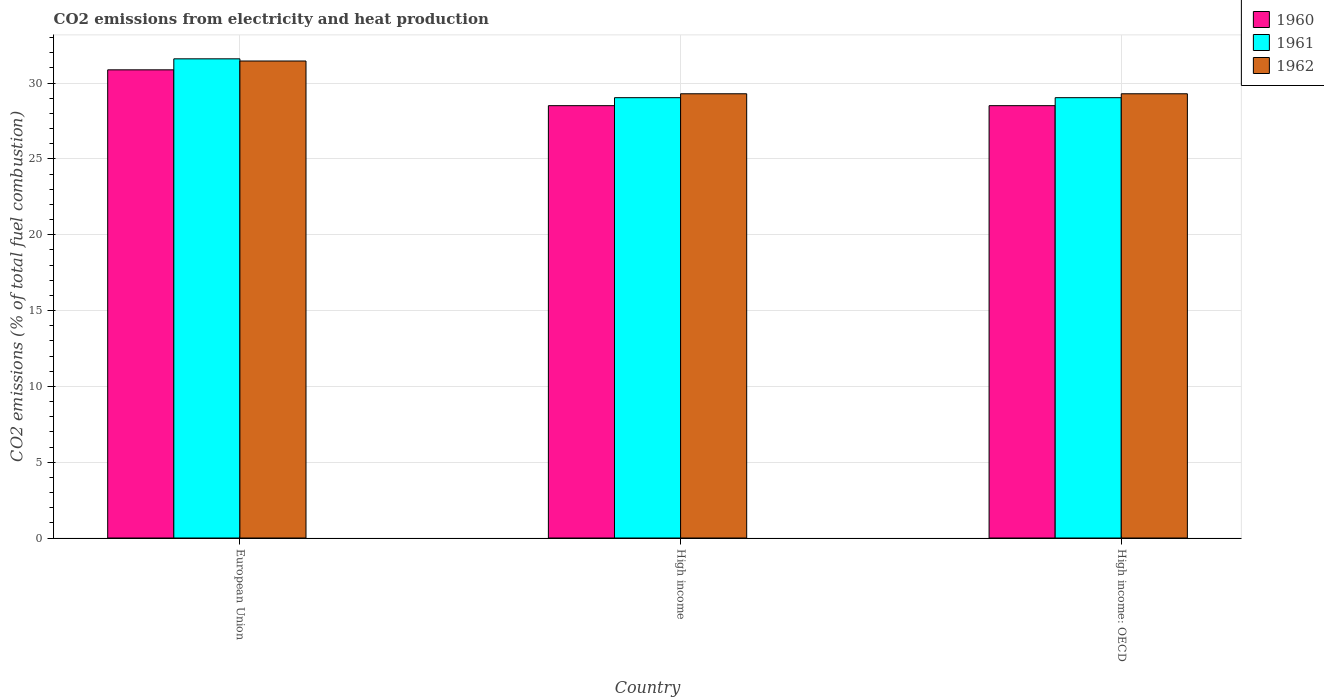How many groups of bars are there?
Make the answer very short. 3. How many bars are there on the 2nd tick from the left?
Offer a terse response. 3. How many bars are there on the 1st tick from the right?
Provide a short and direct response. 3. What is the amount of CO2 emitted in 1961 in European Union?
Make the answer very short. 31.59. Across all countries, what is the maximum amount of CO2 emitted in 1961?
Your answer should be very brief. 31.59. Across all countries, what is the minimum amount of CO2 emitted in 1960?
Give a very brief answer. 28.51. In which country was the amount of CO2 emitted in 1961 maximum?
Ensure brevity in your answer.  European Union. What is the total amount of CO2 emitted in 1960 in the graph?
Provide a succinct answer. 87.88. What is the difference between the amount of CO2 emitted in 1960 in European Union and that in High income: OECD?
Provide a short and direct response. 2.36. What is the difference between the amount of CO2 emitted in 1960 in European Union and the amount of CO2 emitted in 1962 in High income: OECD?
Provide a succinct answer. 1.58. What is the average amount of CO2 emitted in 1961 per country?
Keep it short and to the point. 29.89. What is the difference between the amount of CO2 emitted of/in 1961 and amount of CO2 emitted of/in 1962 in European Union?
Your answer should be very brief. 0.14. In how many countries, is the amount of CO2 emitted in 1961 greater than 14 %?
Keep it short and to the point. 3. Is the amount of CO2 emitted in 1960 in High income less than that in High income: OECD?
Keep it short and to the point. No. Is the difference between the amount of CO2 emitted in 1961 in European Union and High income greater than the difference between the amount of CO2 emitted in 1962 in European Union and High income?
Provide a succinct answer. Yes. What is the difference between the highest and the second highest amount of CO2 emitted in 1961?
Offer a terse response. -2.56. What is the difference between the highest and the lowest amount of CO2 emitted in 1962?
Your response must be concise. 2.16. In how many countries, is the amount of CO2 emitted in 1962 greater than the average amount of CO2 emitted in 1962 taken over all countries?
Your answer should be compact. 1. What does the 1st bar from the left in High income represents?
Offer a terse response. 1960. How many bars are there?
Keep it short and to the point. 9. How many countries are there in the graph?
Your response must be concise. 3. What is the difference between two consecutive major ticks on the Y-axis?
Provide a succinct answer. 5. Does the graph contain any zero values?
Offer a terse response. No. What is the title of the graph?
Offer a terse response. CO2 emissions from electricity and heat production. Does "2013" appear as one of the legend labels in the graph?
Provide a succinct answer. No. What is the label or title of the X-axis?
Make the answer very short. Country. What is the label or title of the Y-axis?
Ensure brevity in your answer.  CO2 emissions (% of total fuel combustion). What is the CO2 emissions (% of total fuel combustion) of 1960 in European Union?
Provide a short and direct response. 30.87. What is the CO2 emissions (% of total fuel combustion) of 1961 in European Union?
Provide a short and direct response. 31.59. What is the CO2 emissions (% of total fuel combustion) in 1962 in European Union?
Your response must be concise. 31.45. What is the CO2 emissions (% of total fuel combustion) in 1960 in High income?
Ensure brevity in your answer.  28.51. What is the CO2 emissions (% of total fuel combustion) of 1961 in High income?
Offer a very short reply. 29.03. What is the CO2 emissions (% of total fuel combustion) in 1962 in High income?
Provide a short and direct response. 29.29. What is the CO2 emissions (% of total fuel combustion) of 1960 in High income: OECD?
Offer a terse response. 28.51. What is the CO2 emissions (% of total fuel combustion) of 1961 in High income: OECD?
Provide a succinct answer. 29.03. What is the CO2 emissions (% of total fuel combustion) in 1962 in High income: OECD?
Provide a short and direct response. 29.29. Across all countries, what is the maximum CO2 emissions (% of total fuel combustion) of 1960?
Your answer should be very brief. 30.87. Across all countries, what is the maximum CO2 emissions (% of total fuel combustion) of 1961?
Your response must be concise. 31.59. Across all countries, what is the maximum CO2 emissions (% of total fuel combustion) of 1962?
Your answer should be very brief. 31.45. Across all countries, what is the minimum CO2 emissions (% of total fuel combustion) in 1960?
Offer a very short reply. 28.51. Across all countries, what is the minimum CO2 emissions (% of total fuel combustion) in 1961?
Ensure brevity in your answer.  29.03. Across all countries, what is the minimum CO2 emissions (% of total fuel combustion) in 1962?
Your response must be concise. 29.29. What is the total CO2 emissions (% of total fuel combustion) in 1960 in the graph?
Your answer should be very brief. 87.88. What is the total CO2 emissions (% of total fuel combustion) in 1961 in the graph?
Your answer should be compact. 89.66. What is the total CO2 emissions (% of total fuel combustion) in 1962 in the graph?
Ensure brevity in your answer.  90.03. What is the difference between the CO2 emissions (% of total fuel combustion) in 1960 in European Union and that in High income?
Offer a terse response. 2.36. What is the difference between the CO2 emissions (% of total fuel combustion) of 1961 in European Union and that in High income?
Provide a succinct answer. 2.56. What is the difference between the CO2 emissions (% of total fuel combustion) of 1962 in European Union and that in High income?
Your answer should be very brief. 2.16. What is the difference between the CO2 emissions (% of total fuel combustion) of 1960 in European Union and that in High income: OECD?
Provide a succinct answer. 2.36. What is the difference between the CO2 emissions (% of total fuel combustion) in 1961 in European Union and that in High income: OECD?
Give a very brief answer. 2.56. What is the difference between the CO2 emissions (% of total fuel combustion) in 1962 in European Union and that in High income: OECD?
Make the answer very short. 2.16. What is the difference between the CO2 emissions (% of total fuel combustion) of 1960 in European Union and the CO2 emissions (% of total fuel combustion) of 1961 in High income?
Provide a short and direct response. 1.84. What is the difference between the CO2 emissions (% of total fuel combustion) in 1960 in European Union and the CO2 emissions (% of total fuel combustion) in 1962 in High income?
Provide a short and direct response. 1.58. What is the difference between the CO2 emissions (% of total fuel combustion) in 1961 in European Union and the CO2 emissions (% of total fuel combustion) in 1962 in High income?
Your answer should be compact. 2.3. What is the difference between the CO2 emissions (% of total fuel combustion) of 1960 in European Union and the CO2 emissions (% of total fuel combustion) of 1961 in High income: OECD?
Ensure brevity in your answer.  1.84. What is the difference between the CO2 emissions (% of total fuel combustion) in 1960 in European Union and the CO2 emissions (% of total fuel combustion) in 1962 in High income: OECD?
Ensure brevity in your answer.  1.58. What is the difference between the CO2 emissions (% of total fuel combustion) in 1961 in European Union and the CO2 emissions (% of total fuel combustion) in 1962 in High income: OECD?
Keep it short and to the point. 2.3. What is the difference between the CO2 emissions (% of total fuel combustion) of 1960 in High income and the CO2 emissions (% of total fuel combustion) of 1961 in High income: OECD?
Your answer should be compact. -0.53. What is the difference between the CO2 emissions (% of total fuel combustion) of 1960 in High income and the CO2 emissions (% of total fuel combustion) of 1962 in High income: OECD?
Ensure brevity in your answer.  -0.78. What is the difference between the CO2 emissions (% of total fuel combustion) in 1961 in High income and the CO2 emissions (% of total fuel combustion) in 1962 in High income: OECD?
Your answer should be very brief. -0.26. What is the average CO2 emissions (% of total fuel combustion) in 1960 per country?
Make the answer very short. 29.29. What is the average CO2 emissions (% of total fuel combustion) of 1961 per country?
Give a very brief answer. 29.89. What is the average CO2 emissions (% of total fuel combustion) of 1962 per country?
Give a very brief answer. 30.01. What is the difference between the CO2 emissions (% of total fuel combustion) of 1960 and CO2 emissions (% of total fuel combustion) of 1961 in European Union?
Your answer should be compact. -0.73. What is the difference between the CO2 emissions (% of total fuel combustion) of 1960 and CO2 emissions (% of total fuel combustion) of 1962 in European Union?
Your answer should be compact. -0.58. What is the difference between the CO2 emissions (% of total fuel combustion) of 1961 and CO2 emissions (% of total fuel combustion) of 1962 in European Union?
Offer a very short reply. 0.14. What is the difference between the CO2 emissions (% of total fuel combustion) in 1960 and CO2 emissions (% of total fuel combustion) in 1961 in High income?
Give a very brief answer. -0.53. What is the difference between the CO2 emissions (% of total fuel combustion) of 1960 and CO2 emissions (% of total fuel combustion) of 1962 in High income?
Provide a short and direct response. -0.78. What is the difference between the CO2 emissions (% of total fuel combustion) in 1961 and CO2 emissions (% of total fuel combustion) in 1962 in High income?
Give a very brief answer. -0.26. What is the difference between the CO2 emissions (% of total fuel combustion) in 1960 and CO2 emissions (% of total fuel combustion) in 1961 in High income: OECD?
Give a very brief answer. -0.53. What is the difference between the CO2 emissions (% of total fuel combustion) of 1960 and CO2 emissions (% of total fuel combustion) of 1962 in High income: OECD?
Make the answer very short. -0.78. What is the difference between the CO2 emissions (% of total fuel combustion) in 1961 and CO2 emissions (% of total fuel combustion) in 1962 in High income: OECD?
Offer a very short reply. -0.26. What is the ratio of the CO2 emissions (% of total fuel combustion) of 1960 in European Union to that in High income?
Offer a terse response. 1.08. What is the ratio of the CO2 emissions (% of total fuel combustion) of 1961 in European Union to that in High income?
Provide a short and direct response. 1.09. What is the ratio of the CO2 emissions (% of total fuel combustion) in 1962 in European Union to that in High income?
Your answer should be compact. 1.07. What is the ratio of the CO2 emissions (% of total fuel combustion) of 1960 in European Union to that in High income: OECD?
Your response must be concise. 1.08. What is the ratio of the CO2 emissions (% of total fuel combustion) in 1961 in European Union to that in High income: OECD?
Your answer should be very brief. 1.09. What is the ratio of the CO2 emissions (% of total fuel combustion) of 1962 in European Union to that in High income: OECD?
Your answer should be very brief. 1.07. What is the ratio of the CO2 emissions (% of total fuel combustion) of 1960 in High income to that in High income: OECD?
Offer a terse response. 1. What is the ratio of the CO2 emissions (% of total fuel combustion) in 1962 in High income to that in High income: OECD?
Offer a terse response. 1. What is the difference between the highest and the second highest CO2 emissions (% of total fuel combustion) of 1960?
Your response must be concise. 2.36. What is the difference between the highest and the second highest CO2 emissions (% of total fuel combustion) of 1961?
Keep it short and to the point. 2.56. What is the difference between the highest and the second highest CO2 emissions (% of total fuel combustion) in 1962?
Ensure brevity in your answer.  2.16. What is the difference between the highest and the lowest CO2 emissions (% of total fuel combustion) of 1960?
Keep it short and to the point. 2.36. What is the difference between the highest and the lowest CO2 emissions (% of total fuel combustion) of 1961?
Provide a short and direct response. 2.56. What is the difference between the highest and the lowest CO2 emissions (% of total fuel combustion) in 1962?
Your answer should be compact. 2.16. 